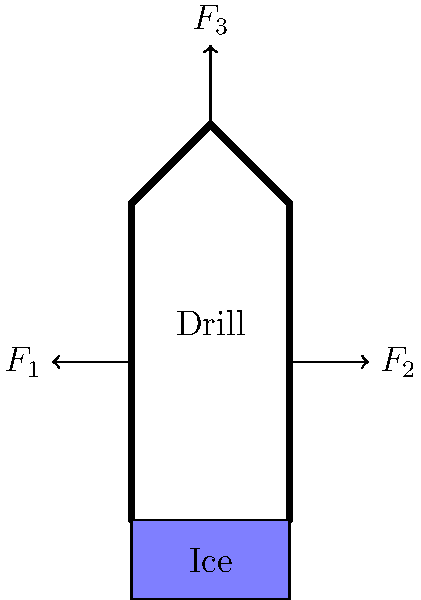As an Arctic exploration enthusiast, you're studying ice core drilling equipment. The diagram shows a simplified force analysis of an ice core drill. If the horizontal force $F_1 = 500$ N, the vertical force $F_3 = 1000$ N, and the drill is in equilibrium, what is the magnitude of the horizontal force $F_2$? To solve this problem, we'll follow these steps:

1. Recognize that the drill is in equilibrium, which means the sum of all forces must be zero in both horizontal and vertical directions.

2. For horizontal equilibrium:
   $$\sum F_x = 0$$
   $$F_2 - F_1 = 0$$

3. We know $F_1 = 500$ N, so we can substitute this value:
   $$F_2 - 500 = 0$$

4. Solve for $F_2$:
   $$F_2 = 500 \text{ N}$$

5. Note that the vertical force $F_3$ doesn't affect the horizontal equilibrium, so it's not needed for this calculation.

6. The magnitude of $F_2$ is equal to $F_1$, which makes sense as they are directly opposing forces in equilibrium.
Answer: 500 N 